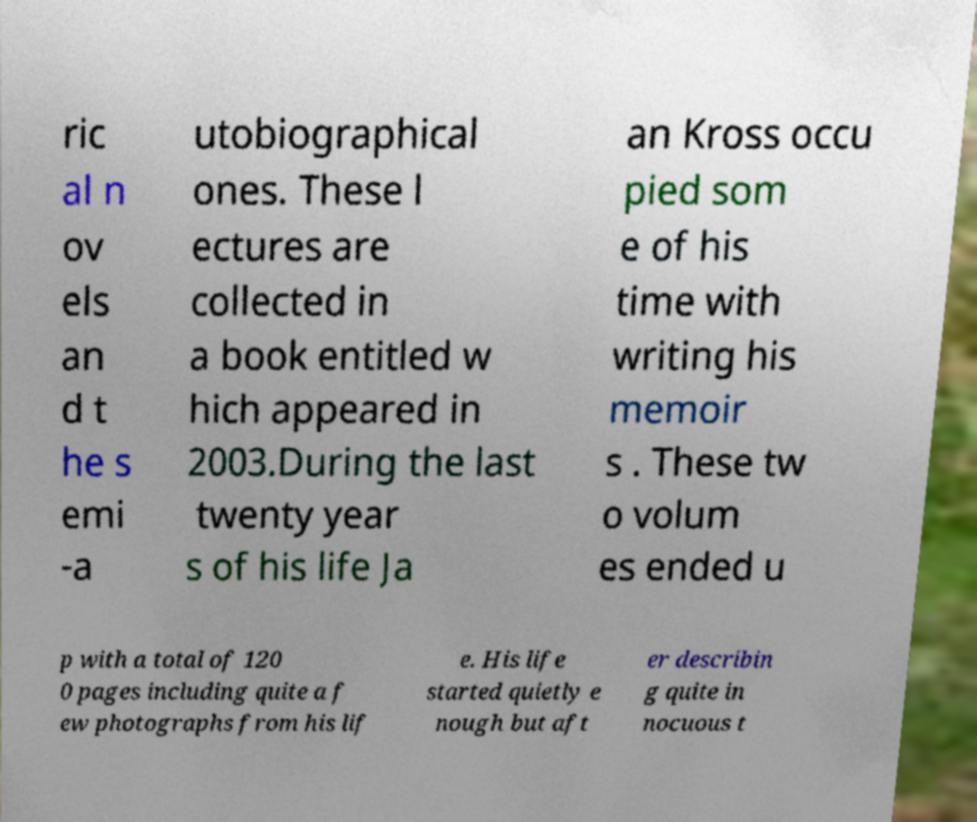Can you read and provide the text displayed in the image?This photo seems to have some interesting text. Can you extract and type it out for me? ric al n ov els an d t he s emi -a utobiographical ones. These l ectures are collected in a book entitled w hich appeared in 2003.During the last twenty year s of his life Ja an Kross occu pied som e of his time with writing his memoir s . These tw o volum es ended u p with a total of 120 0 pages including quite a f ew photographs from his lif e. His life started quietly e nough but aft er describin g quite in nocuous t 